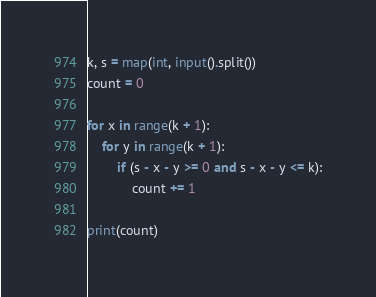<code> <loc_0><loc_0><loc_500><loc_500><_Python_>k, s = map(int, input().split())
count = 0

for x in range(k + 1):
    for y in range(k + 1):
        if (s - x - y >= 0 and s - x - y <= k):
            count += 1

print(count)
</code> 